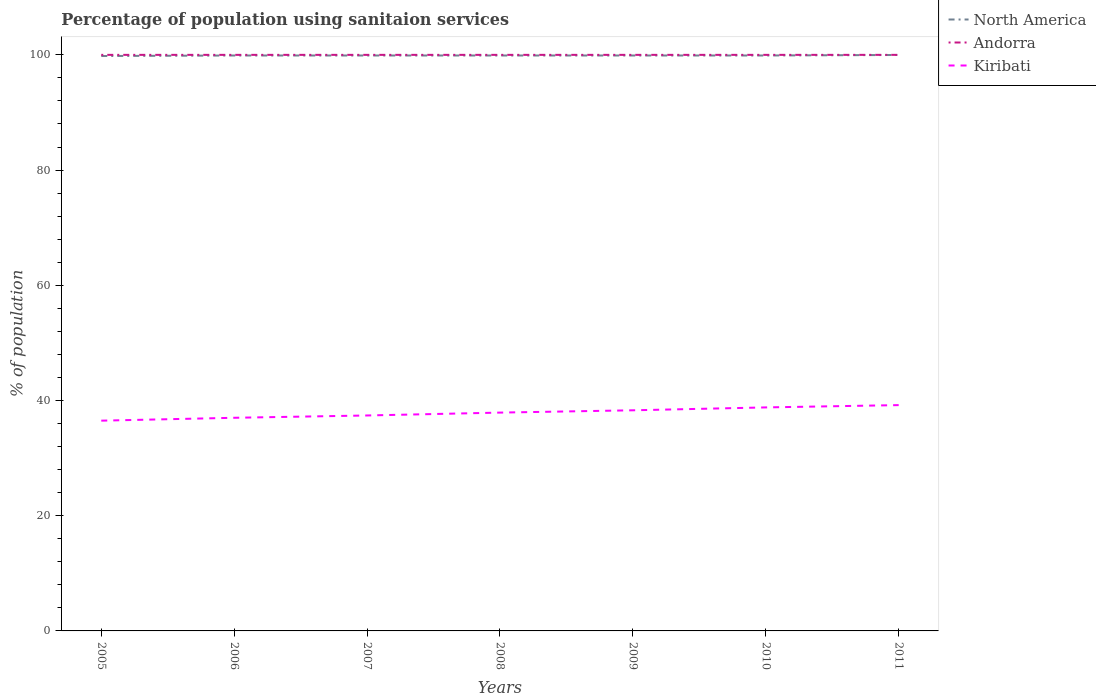How many different coloured lines are there?
Offer a terse response. 3. Does the line corresponding to Kiribati intersect with the line corresponding to North America?
Provide a succinct answer. No. Across all years, what is the maximum percentage of population using sanitaion services in Andorra?
Your answer should be very brief. 100. What is the total percentage of population using sanitaion services in Kiribati in the graph?
Ensure brevity in your answer.  -1.8. What is the difference between the highest and the second highest percentage of population using sanitaion services in North America?
Your answer should be very brief. 0.18. Is the percentage of population using sanitaion services in North America strictly greater than the percentage of population using sanitaion services in Kiribati over the years?
Make the answer very short. No. What is the difference between two consecutive major ticks on the Y-axis?
Your answer should be compact. 20. Are the values on the major ticks of Y-axis written in scientific E-notation?
Offer a very short reply. No. Does the graph contain any zero values?
Give a very brief answer. No. How many legend labels are there?
Give a very brief answer. 3. What is the title of the graph?
Ensure brevity in your answer.  Percentage of population using sanitaion services. Does "Small states" appear as one of the legend labels in the graph?
Provide a short and direct response. No. What is the label or title of the Y-axis?
Provide a succinct answer. % of population. What is the % of population in North America in 2005?
Offer a very short reply. 99.8. What is the % of population of Andorra in 2005?
Your answer should be very brief. 100. What is the % of population of Kiribati in 2005?
Provide a short and direct response. 36.5. What is the % of population of North America in 2006?
Your answer should be very brief. 99.89. What is the % of population of Andorra in 2006?
Provide a succinct answer. 100. What is the % of population in Kiribati in 2006?
Make the answer very short. 37. What is the % of population of North America in 2007?
Provide a short and direct response. 99.89. What is the % of population of Kiribati in 2007?
Your answer should be very brief. 37.4. What is the % of population in North America in 2008?
Give a very brief answer. 99.89. What is the % of population in Andorra in 2008?
Your response must be concise. 100. What is the % of population of Kiribati in 2008?
Give a very brief answer. 37.9. What is the % of population in North America in 2009?
Keep it short and to the point. 99.89. What is the % of population of Andorra in 2009?
Make the answer very short. 100. What is the % of population in Kiribati in 2009?
Ensure brevity in your answer.  38.3. What is the % of population in North America in 2010?
Ensure brevity in your answer.  99.89. What is the % of population of Kiribati in 2010?
Keep it short and to the point. 38.8. What is the % of population of North America in 2011?
Provide a succinct answer. 99.98. What is the % of population in Kiribati in 2011?
Ensure brevity in your answer.  39.2. Across all years, what is the maximum % of population of North America?
Your response must be concise. 99.98. Across all years, what is the maximum % of population of Andorra?
Provide a succinct answer. 100. Across all years, what is the maximum % of population of Kiribati?
Offer a terse response. 39.2. Across all years, what is the minimum % of population of North America?
Provide a short and direct response. 99.8. Across all years, what is the minimum % of population of Andorra?
Ensure brevity in your answer.  100. Across all years, what is the minimum % of population in Kiribati?
Provide a short and direct response. 36.5. What is the total % of population of North America in the graph?
Ensure brevity in your answer.  699.23. What is the total % of population in Andorra in the graph?
Give a very brief answer. 700. What is the total % of population in Kiribati in the graph?
Keep it short and to the point. 265.1. What is the difference between the % of population of North America in 2005 and that in 2006?
Your response must be concise. -0.09. What is the difference between the % of population in North America in 2005 and that in 2007?
Make the answer very short. -0.09. What is the difference between the % of population in North America in 2005 and that in 2008?
Your answer should be compact. -0.09. What is the difference between the % of population of Kiribati in 2005 and that in 2008?
Your answer should be compact. -1.4. What is the difference between the % of population of North America in 2005 and that in 2009?
Provide a short and direct response. -0.09. What is the difference between the % of population of Andorra in 2005 and that in 2009?
Your answer should be very brief. 0. What is the difference between the % of population in North America in 2005 and that in 2010?
Provide a short and direct response. -0.09. What is the difference between the % of population in Andorra in 2005 and that in 2010?
Keep it short and to the point. 0. What is the difference between the % of population in Kiribati in 2005 and that in 2010?
Ensure brevity in your answer.  -2.3. What is the difference between the % of population of North America in 2005 and that in 2011?
Keep it short and to the point. -0.18. What is the difference between the % of population of Andorra in 2005 and that in 2011?
Offer a very short reply. 0. What is the difference between the % of population of Kiribati in 2006 and that in 2009?
Ensure brevity in your answer.  -1.3. What is the difference between the % of population of North America in 2006 and that in 2010?
Give a very brief answer. 0. What is the difference between the % of population in Andorra in 2006 and that in 2010?
Your response must be concise. 0. What is the difference between the % of population of North America in 2006 and that in 2011?
Offer a very short reply. -0.09. What is the difference between the % of population of North America in 2007 and that in 2008?
Provide a short and direct response. 0. What is the difference between the % of population in North America in 2007 and that in 2010?
Your answer should be very brief. 0. What is the difference between the % of population of Andorra in 2007 and that in 2010?
Your response must be concise. 0. What is the difference between the % of population in Kiribati in 2007 and that in 2010?
Make the answer very short. -1.4. What is the difference between the % of population of North America in 2007 and that in 2011?
Provide a short and direct response. -0.09. What is the difference between the % of population of Andorra in 2007 and that in 2011?
Offer a terse response. 0. What is the difference between the % of population in Kiribati in 2007 and that in 2011?
Keep it short and to the point. -1.8. What is the difference between the % of population in North America in 2008 and that in 2009?
Keep it short and to the point. 0. What is the difference between the % of population of Andorra in 2008 and that in 2009?
Provide a short and direct response. 0. What is the difference between the % of population of North America in 2008 and that in 2010?
Provide a succinct answer. 0. What is the difference between the % of population of North America in 2008 and that in 2011?
Give a very brief answer. -0.09. What is the difference between the % of population of Kiribati in 2008 and that in 2011?
Your answer should be compact. -1.3. What is the difference between the % of population in North America in 2009 and that in 2010?
Offer a terse response. 0. What is the difference between the % of population of Kiribati in 2009 and that in 2010?
Your response must be concise. -0.5. What is the difference between the % of population in North America in 2009 and that in 2011?
Ensure brevity in your answer.  -0.09. What is the difference between the % of population in North America in 2010 and that in 2011?
Provide a succinct answer. -0.09. What is the difference between the % of population of North America in 2005 and the % of population of Andorra in 2006?
Make the answer very short. -0.2. What is the difference between the % of population in North America in 2005 and the % of population in Kiribati in 2006?
Provide a short and direct response. 62.8. What is the difference between the % of population in North America in 2005 and the % of population in Kiribati in 2007?
Your answer should be compact. 62.4. What is the difference between the % of population in Andorra in 2005 and the % of population in Kiribati in 2007?
Keep it short and to the point. 62.6. What is the difference between the % of population in North America in 2005 and the % of population in Kiribati in 2008?
Keep it short and to the point. 61.9. What is the difference between the % of population in Andorra in 2005 and the % of population in Kiribati in 2008?
Your answer should be very brief. 62.1. What is the difference between the % of population in North America in 2005 and the % of population in Andorra in 2009?
Your answer should be compact. -0.2. What is the difference between the % of population in North America in 2005 and the % of population in Kiribati in 2009?
Your answer should be very brief. 61.5. What is the difference between the % of population in Andorra in 2005 and the % of population in Kiribati in 2009?
Keep it short and to the point. 61.7. What is the difference between the % of population of North America in 2005 and the % of population of Kiribati in 2010?
Offer a terse response. 61. What is the difference between the % of population in Andorra in 2005 and the % of population in Kiribati in 2010?
Give a very brief answer. 61.2. What is the difference between the % of population of North America in 2005 and the % of population of Kiribati in 2011?
Make the answer very short. 60.6. What is the difference between the % of population in Andorra in 2005 and the % of population in Kiribati in 2011?
Ensure brevity in your answer.  60.8. What is the difference between the % of population of North America in 2006 and the % of population of Andorra in 2007?
Keep it short and to the point. -0.11. What is the difference between the % of population in North America in 2006 and the % of population in Kiribati in 2007?
Give a very brief answer. 62.49. What is the difference between the % of population in Andorra in 2006 and the % of population in Kiribati in 2007?
Ensure brevity in your answer.  62.6. What is the difference between the % of population in North America in 2006 and the % of population in Andorra in 2008?
Your answer should be compact. -0.11. What is the difference between the % of population of North America in 2006 and the % of population of Kiribati in 2008?
Offer a very short reply. 61.99. What is the difference between the % of population in Andorra in 2006 and the % of population in Kiribati in 2008?
Keep it short and to the point. 62.1. What is the difference between the % of population of North America in 2006 and the % of population of Andorra in 2009?
Your response must be concise. -0.11. What is the difference between the % of population in North America in 2006 and the % of population in Kiribati in 2009?
Your answer should be compact. 61.59. What is the difference between the % of population of Andorra in 2006 and the % of population of Kiribati in 2009?
Your response must be concise. 61.7. What is the difference between the % of population of North America in 2006 and the % of population of Andorra in 2010?
Offer a terse response. -0.11. What is the difference between the % of population in North America in 2006 and the % of population in Kiribati in 2010?
Your response must be concise. 61.09. What is the difference between the % of population in Andorra in 2006 and the % of population in Kiribati in 2010?
Your response must be concise. 61.2. What is the difference between the % of population in North America in 2006 and the % of population in Andorra in 2011?
Your answer should be compact. -0.11. What is the difference between the % of population of North America in 2006 and the % of population of Kiribati in 2011?
Make the answer very short. 60.69. What is the difference between the % of population of Andorra in 2006 and the % of population of Kiribati in 2011?
Your response must be concise. 60.8. What is the difference between the % of population in North America in 2007 and the % of population in Andorra in 2008?
Your answer should be compact. -0.11. What is the difference between the % of population of North America in 2007 and the % of population of Kiribati in 2008?
Make the answer very short. 61.99. What is the difference between the % of population in Andorra in 2007 and the % of population in Kiribati in 2008?
Your answer should be compact. 62.1. What is the difference between the % of population in North America in 2007 and the % of population in Andorra in 2009?
Offer a terse response. -0.11. What is the difference between the % of population in North America in 2007 and the % of population in Kiribati in 2009?
Keep it short and to the point. 61.59. What is the difference between the % of population in Andorra in 2007 and the % of population in Kiribati in 2009?
Offer a very short reply. 61.7. What is the difference between the % of population of North America in 2007 and the % of population of Andorra in 2010?
Make the answer very short. -0.11. What is the difference between the % of population in North America in 2007 and the % of population in Kiribati in 2010?
Offer a very short reply. 61.09. What is the difference between the % of population of Andorra in 2007 and the % of population of Kiribati in 2010?
Your answer should be compact. 61.2. What is the difference between the % of population in North America in 2007 and the % of population in Andorra in 2011?
Offer a very short reply. -0.11. What is the difference between the % of population in North America in 2007 and the % of population in Kiribati in 2011?
Your answer should be very brief. 60.69. What is the difference between the % of population of Andorra in 2007 and the % of population of Kiribati in 2011?
Offer a terse response. 60.8. What is the difference between the % of population in North America in 2008 and the % of population in Andorra in 2009?
Offer a terse response. -0.11. What is the difference between the % of population in North America in 2008 and the % of population in Kiribati in 2009?
Provide a succinct answer. 61.59. What is the difference between the % of population of Andorra in 2008 and the % of population of Kiribati in 2009?
Make the answer very short. 61.7. What is the difference between the % of population in North America in 2008 and the % of population in Andorra in 2010?
Your answer should be compact. -0.11. What is the difference between the % of population of North America in 2008 and the % of population of Kiribati in 2010?
Make the answer very short. 61.09. What is the difference between the % of population in Andorra in 2008 and the % of population in Kiribati in 2010?
Give a very brief answer. 61.2. What is the difference between the % of population of North America in 2008 and the % of population of Andorra in 2011?
Keep it short and to the point. -0.11. What is the difference between the % of population in North America in 2008 and the % of population in Kiribati in 2011?
Your answer should be compact. 60.69. What is the difference between the % of population of Andorra in 2008 and the % of population of Kiribati in 2011?
Keep it short and to the point. 60.8. What is the difference between the % of population of North America in 2009 and the % of population of Andorra in 2010?
Provide a short and direct response. -0.11. What is the difference between the % of population of North America in 2009 and the % of population of Kiribati in 2010?
Offer a terse response. 61.09. What is the difference between the % of population of Andorra in 2009 and the % of population of Kiribati in 2010?
Make the answer very short. 61.2. What is the difference between the % of population in North America in 2009 and the % of population in Andorra in 2011?
Your response must be concise. -0.11. What is the difference between the % of population in North America in 2009 and the % of population in Kiribati in 2011?
Provide a succinct answer. 60.69. What is the difference between the % of population of Andorra in 2009 and the % of population of Kiribati in 2011?
Provide a short and direct response. 60.8. What is the difference between the % of population in North America in 2010 and the % of population in Andorra in 2011?
Offer a terse response. -0.11. What is the difference between the % of population in North America in 2010 and the % of population in Kiribati in 2011?
Your answer should be very brief. 60.69. What is the difference between the % of population of Andorra in 2010 and the % of population of Kiribati in 2011?
Your response must be concise. 60.8. What is the average % of population of North America per year?
Provide a short and direct response. 99.89. What is the average % of population in Kiribati per year?
Make the answer very short. 37.87. In the year 2005, what is the difference between the % of population of North America and % of population of Andorra?
Your answer should be very brief. -0.2. In the year 2005, what is the difference between the % of population in North America and % of population in Kiribati?
Ensure brevity in your answer.  63.3. In the year 2005, what is the difference between the % of population in Andorra and % of population in Kiribati?
Your answer should be compact. 63.5. In the year 2006, what is the difference between the % of population in North America and % of population in Andorra?
Your answer should be very brief. -0.11. In the year 2006, what is the difference between the % of population in North America and % of population in Kiribati?
Your response must be concise. 62.89. In the year 2007, what is the difference between the % of population of North America and % of population of Andorra?
Keep it short and to the point. -0.11. In the year 2007, what is the difference between the % of population of North America and % of population of Kiribati?
Your response must be concise. 62.49. In the year 2007, what is the difference between the % of population in Andorra and % of population in Kiribati?
Provide a short and direct response. 62.6. In the year 2008, what is the difference between the % of population of North America and % of population of Andorra?
Make the answer very short. -0.11. In the year 2008, what is the difference between the % of population in North America and % of population in Kiribati?
Your answer should be compact. 61.99. In the year 2008, what is the difference between the % of population in Andorra and % of population in Kiribati?
Ensure brevity in your answer.  62.1. In the year 2009, what is the difference between the % of population in North America and % of population in Andorra?
Your answer should be very brief. -0.11. In the year 2009, what is the difference between the % of population of North America and % of population of Kiribati?
Provide a succinct answer. 61.59. In the year 2009, what is the difference between the % of population in Andorra and % of population in Kiribati?
Give a very brief answer. 61.7. In the year 2010, what is the difference between the % of population in North America and % of population in Andorra?
Your response must be concise. -0.11. In the year 2010, what is the difference between the % of population in North America and % of population in Kiribati?
Provide a succinct answer. 61.09. In the year 2010, what is the difference between the % of population of Andorra and % of population of Kiribati?
Provide a short and direct response. 61.2. In the year 2011, what is the difference between the % of population of North America and % of population of Andorra?
Keep it short and to the point. -0.02. In the year 2011, what is the difference between the % of population of North America and % of population of Kiribati?
Offer a very short reply. 60.78. In the year 2011, what is the difference between the % of population of Andorra and % of population of Kiribati?
Provide a short and direct response. 60.8. What is the ratio of the % of population of Kiribati in 2005 to that in 2006?
Ensure brevity in your answer.  0.99. What is the ratio of the % of population in North America in 2005 to that in 2007?
Provide a succinct answer. 1. What is the ratio of the % of population in Kiribati in 2005 to that in 2007?
Offer a terse response. 0.98. What is the ratio of the % of population in Andorra in 2005 to that in 2008?
Your response must be concise. 1. What is the ratio of the % of population in Kiribati in 2005 to that in 2008?
Offer a very short reply. 0.96. What is the ratio of the % of population of Andorra in 2005 to that in 2009?
Give a very brief answer. 1. What is the ratio of the % of population in Kiribati in 2005 to that in 2009?
Your answer should be very brief. 0.95. What is the ratio of the % of population of Andorra in 2005 to that in 2010?
Provide a short and direct response. 1. What is the ratio of the % of population in Kiribati in 2005 to that in 2010?
Your answer should be compact. 0.94. What is the ratio of the % of population in Andorra in 2005 to that in 2011?
Provide a short and direct response. 1. What is the ratio of the % of population of Kiribati in 2005 to that in 2011?
Provide a short and direct response. 0.93. What is the ratio of the % of population of Andorra in 2006 to that in 2007?
Offer a very short reply. 1. What is the ratio of the % of population of Kiribati in 2006 to that in 2007?
Give a very brief answer. 0.99. What is the ratio of the % of population in Kiribati in 2006 to that in 2008?
Offer a terse response. 0.98. What is the ratio of the % of population of Kiribati in 2006 to that in 2009?
Your response must be concise. 0.97. What is the ratio of the % of population in North America in 2006 to that in 2010?
Provide a short and direct response. 1. What is the ratio of the % of population of Kiribati in 2006 to that in 2010?
Offer a very short reply. 0.95. What is the ratio of the % of population in Andorra in 2006 to that in 2011?
Provide a short and direct response. 1. What is the ratio of the % of population in Kiribati in 2006 to that in 2011?
Keep it short and to the point. 0.94. What is the ratio of the % of population in North America in 2007 to that in 2008?
Ensure brevity in your answer.  1. What is the ratio of the % of population of North America in 2007 to that in 2009?
Make the answer very short. 1. What is the ratio of the % of population of Andorra in 2007 to that in 2009?
Your answer should be very brief. 1. What is the ratio of the % of population in Kiribati in 2007 to that in 2009?
Keep it short and to the point. 0.98. What is the ratio of the % of population in North America in 2007 to that in 2010?
Offer a very short reply. 1. What is the ratio of the % of population of Kiribati in 2007 to that in 2010?
Keep it short and to the point. 0.96. What is the ratio of the % of population of Andorra in 2007 to that in 2011?
Provide a short and direct response. 1. What is the ratio of the % of population of Kiribati in 2007 to that in 2011?
Give a very brief answer. 0.95. What is the ratio of the % of population in Kiribati in 2008 to that in 2009?
Offer a terse response. 0.99. What is the ratio of the % of population of North America in 2008 to that in 2010?
Give a very brief answer. 1. What is the ratio of the % of population in Andorra in 2008 to that in 2010?
Ensure brevity in your answer.  1. What is the ratio of the % of population in Kiribati in 2008 to that in 2010?
Provide a short and direct response. 0.98. What is the ratio of the % of population in North America in 2008 to that in 2011?
Provide a succinct answer. 1. What is the ratio of the % of population in Andorra in 2008 to that in 2011?
Make the answer very short. 1. What is the ratio of the % of population in Kiribati in 2008 to that in 2011?
Your answer should be very brief. 0.97. What is the ratio of the % of population of North America in 2009 to that in 2010?
Your response must be concise. 1. What is the ratio of the % of population in Kiribati in 2009 to that in 2010?
Your answer should be very brief. 0.99. What is the ratio of the % of population in North America in 2009 to that in 2011?
Offer a terse response. 1. What is the ratio of the % of population in North America in 2010 to that in 2011?
Keep it short and to the point. 1. What is the difference between the highest and the second highest % of population in North America?
Provide a succinct answer. 0.09. What is the difference between the highest and the second highest % of population of Andorra?
Offer a very short reply. 0. What is the difference between the highest and the lowest % of population of North America?
Your answer should be very brief. 0.18. What is the difference between the highest and the lowest % of population in Andorra?
Ensure brevity in your answer.  0. What is the difference between the highest and the lowest % of population in Kiribati?
Provide a succinct answer. 2.7. 